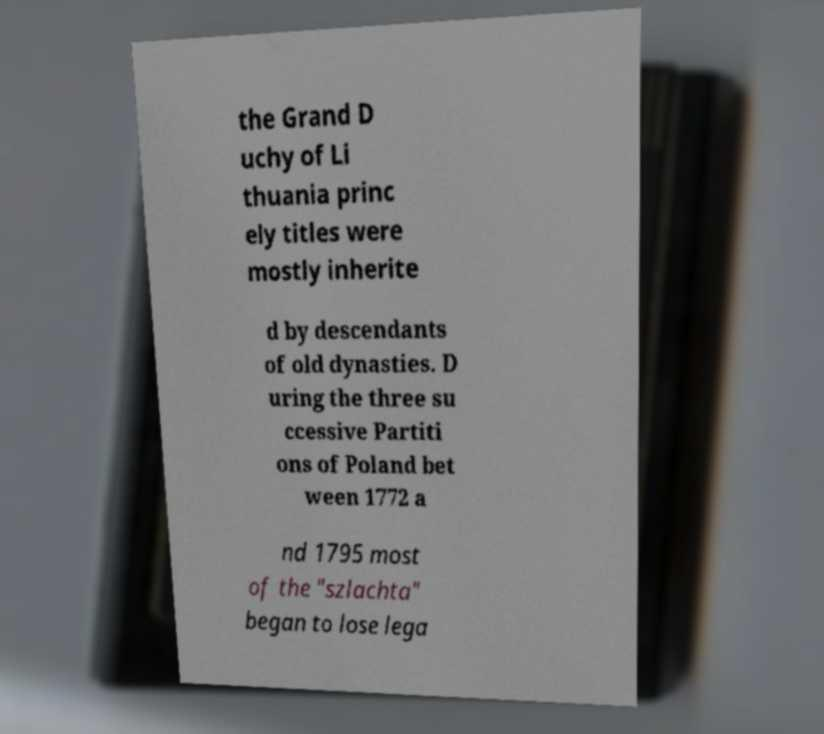What messages or text are displayed in this image? I need them in a readable, typed format. the Grand D uchy of Li thuania princ ely titles were mostly inherite d by descendants of old dynasties. D uring the three su ccessive Partiti ons of Poland bet ween 1772 a nd 1795 most of the "szlachta" began to lose lega 